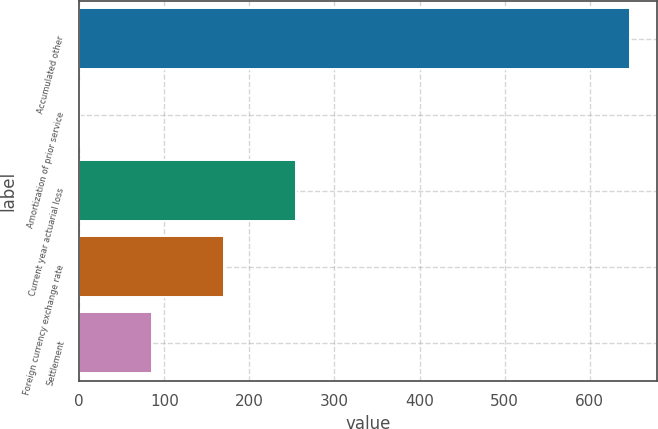Convert chart. <chart><loc_0><loc_0><loc_500><loc_500><bar_chart><fcel>Accumulated other<fcel>Amortization of prior service<fcel>Current year actuarial loss<fcel>Foreign currency exchange rate<fcel>Settlement<nl><fcel>646.9<fcel>0.7<fcel>255.28<fcel>170.42<fcel>85.56<nl></chart> 